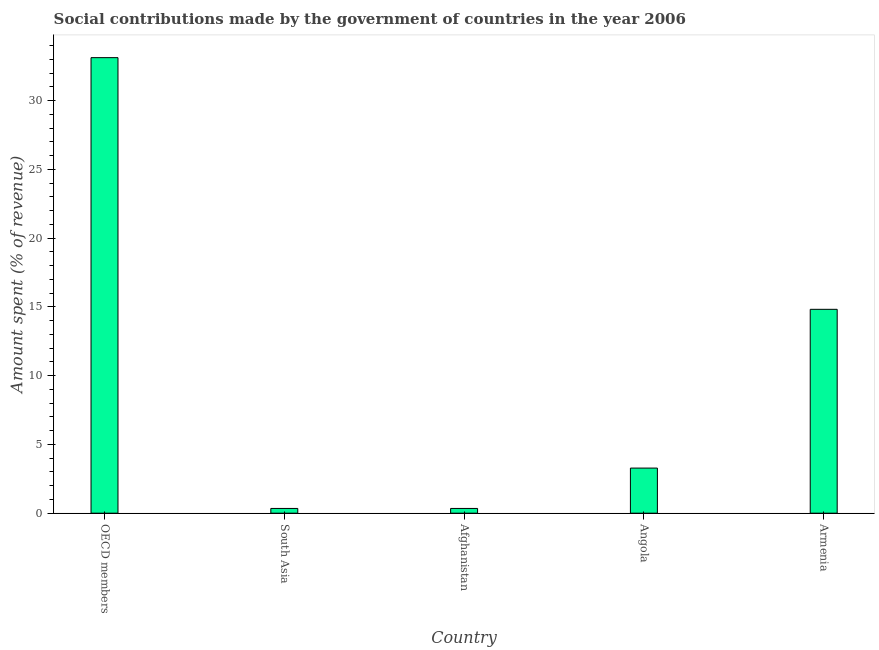Does the graph contain any zero values?
Ensure brevity in your answer.  No. Does the graph contain grids?
Provide a succinct answer. No. What is the title of the graph?
Your answer should be very brief. Social contributions made by the government of countries in the year 2006. What is the label or title of the X-axis?
Ensure brevity in your answer.  Country. What is the label or title of the Y-axis?
Your response must be concise. Amount spent (% of revenue). What is the amount spent in making social contributions in Armenia?
Your answer should be compact. 14.83. Across all countries, what is the maximum amount spent in making social contributions?
Your answer should be very brief. 33.13. Across all countries, what is the minimum amount spent in making social contributions?
Make the answer very short. 0.35. In which country was the amount spent in making social contributions maximum?
Your response must be concise. OECD members. What is the sum of the amount spent in making social contributions?
Provide a succinct answer. 51.92. What is the difference between the amount spent in making social contributions in Afghanistan and Armenia?
Keep it short and to the point. -14.48. What is the average amount spent in making social contributions per country?
Your answer should be compact. 10.38. What is the median amount spent in making social contributions?
Your answer should be compact. 3.28. In how many countries, is the amount spent in making social contributions greater than 8 %?
Your answer should be very brief. 2. What is the ratio of the amount spent in making social contributions in Armenia to that in South Asia?
Keep it short and to the point. 42.89. What is the difference between the highest and the second highest amount spent in making social contributions?
Keep it short and to the point. 18.3. What is the difference between the highest and the lowest amount spent in making social contributions?
Offer a very short reply. 32.78. In how many countries, is the amount spent in making social contributions greater than the average amount spent in making social contributions taken over all countries?
Make the answer very short. 2. How many bars are there?
Your response must be concise. 5. Are all the bars in the graph horizontal?
Provide a short and direct response. No. Are the values on the major ticks of Y-axis written in scientific E-notation?
Provide a short and direct response. No. What is the Amount spent (% of revenue) in OECD members?
Your answer should be very brief. 33.13. What is the Amount spent (% of revenue) of South Asia?
Keep it short and to the point. 0.35. What is the Amount spent (% of revenue) in Afghanistan?
Provide a short and direct response. 0.35. What is the Amount spent (% of revenue) of Angola?
Make the answer very short. 3.28. What is the Amount spent (% of revenue) in Armenia?
Your answer should be compact. 14.83. What is the difference between the Amount spent (% of revenue) in OECD members and South Asia?
Provide a succinct answer. 32.78. What is the difference between the Amount spent (% of revenue) in OECD members and Afghanistan?
Provide a short and direct response. 32.78. What is the difference between the Amount spent (% of revenue) in OECD members and Angola?
Your answer should be very brief. 29.85. What is the difference between the Amount spent (% of revenue) in OECD members and Armenia?
Ensure brevity in your answer.  18.3. What is the difference between the Amount spent (% of revenue) in South Asia and Afghanistan?
Your response must be concise. 0. What is the difference between the Amount spent (% of revenue) in South Asia and Angola?
Make the answer very short. -2.93. What is the difference between the Amount spent (% of revenue) in South Asia and Armenia?
Provide a succinct answer. -14.48. What is the difference between the Amount spent (% of revenue) in Afghanistan and Angola?
Make the answer very short. -2.93. What is the difference between the Amount spent (% of revenue) in Afghanistan and Armenia?
Your answer should be very brief. -14.48. What is the difference between the Amount spent (% of revenue) in Angola and Armenia?
Your answer should be very brief. -11.55. What is the ratio of the Amount spent (% of revenue) in OECD members to that in South Asia?
Give a very brief answer. 95.83. What is the ratio of the Amount spent (% of revenue) in OECD members to that in Afghanistan?
Offer a very short reply. 95.83. What is the ratio of the Amount spent (% of revenue) in OECD members to that in Angola?
Give a very brief answer. 10.1. What is the ratio of the Amount spent (% of revenue) in OECD members to that in Armenia?
Give a very brief answer. 2.23. What is the ratio of the Amount spent (% of revenue) in South Asia to that in Angola?
Give a very brief answer. 0.1. What is the ratio of the Amount spent (% of revenue) in South Asia to that in Armenia?
Keep it short and to the point. 0.02. What is the ratio of the Amount spent (% of revenue) in Afghanistan to that in Angola?
Your answer should be very brief. 0.1. What is the ratio of the Amount spent (% of revenue) in Afghanistan to that in Armenia?
Offer a very short reply. 0.02. What is the ratio of the Amount spent (% of revenue) in Angola to that in Armenia?
Provide a short and direct response. 0.22. 